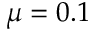<formula> <loc_0><loc_0><loc_500><loc_500>\mu = 0 . 1</formula> 